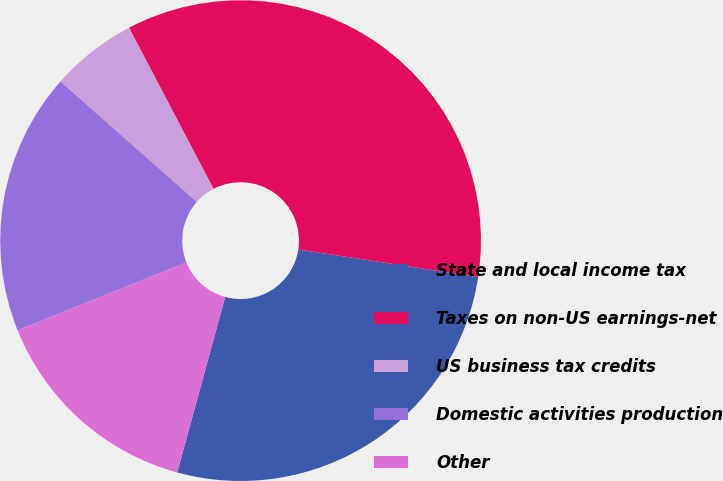<chart> <loc_0><loc_0><loc_500><loc_500><pie_chart><fcel>State and local income tax<fcel>Taxes on non-US earnings-net<fcel>US business tax credits<fcel>Domestic activities production<fcel>Other<nl><fcel>26.83%<fcel>35.11%<fcel>5.8%<fcel>17.6%<fcel>14.67%<nl></chart> 